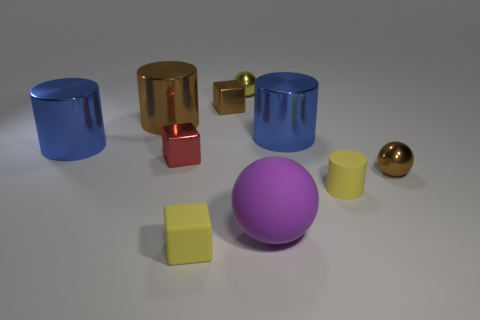Subtract 1 cylinders. How many cylinders are left? 3 Subtract all cylinders. How many objects are left? 6 Subtract all small red shiny things. Subtract all large blue metallic things. How many objects are left? 7 Add 6 rubber things. How many rubber things are left? 9 Add 3 big gray metallic things. How many big gray metallic things exist? 3 Subtract 0 blue cubes. How many objects are left? 10 